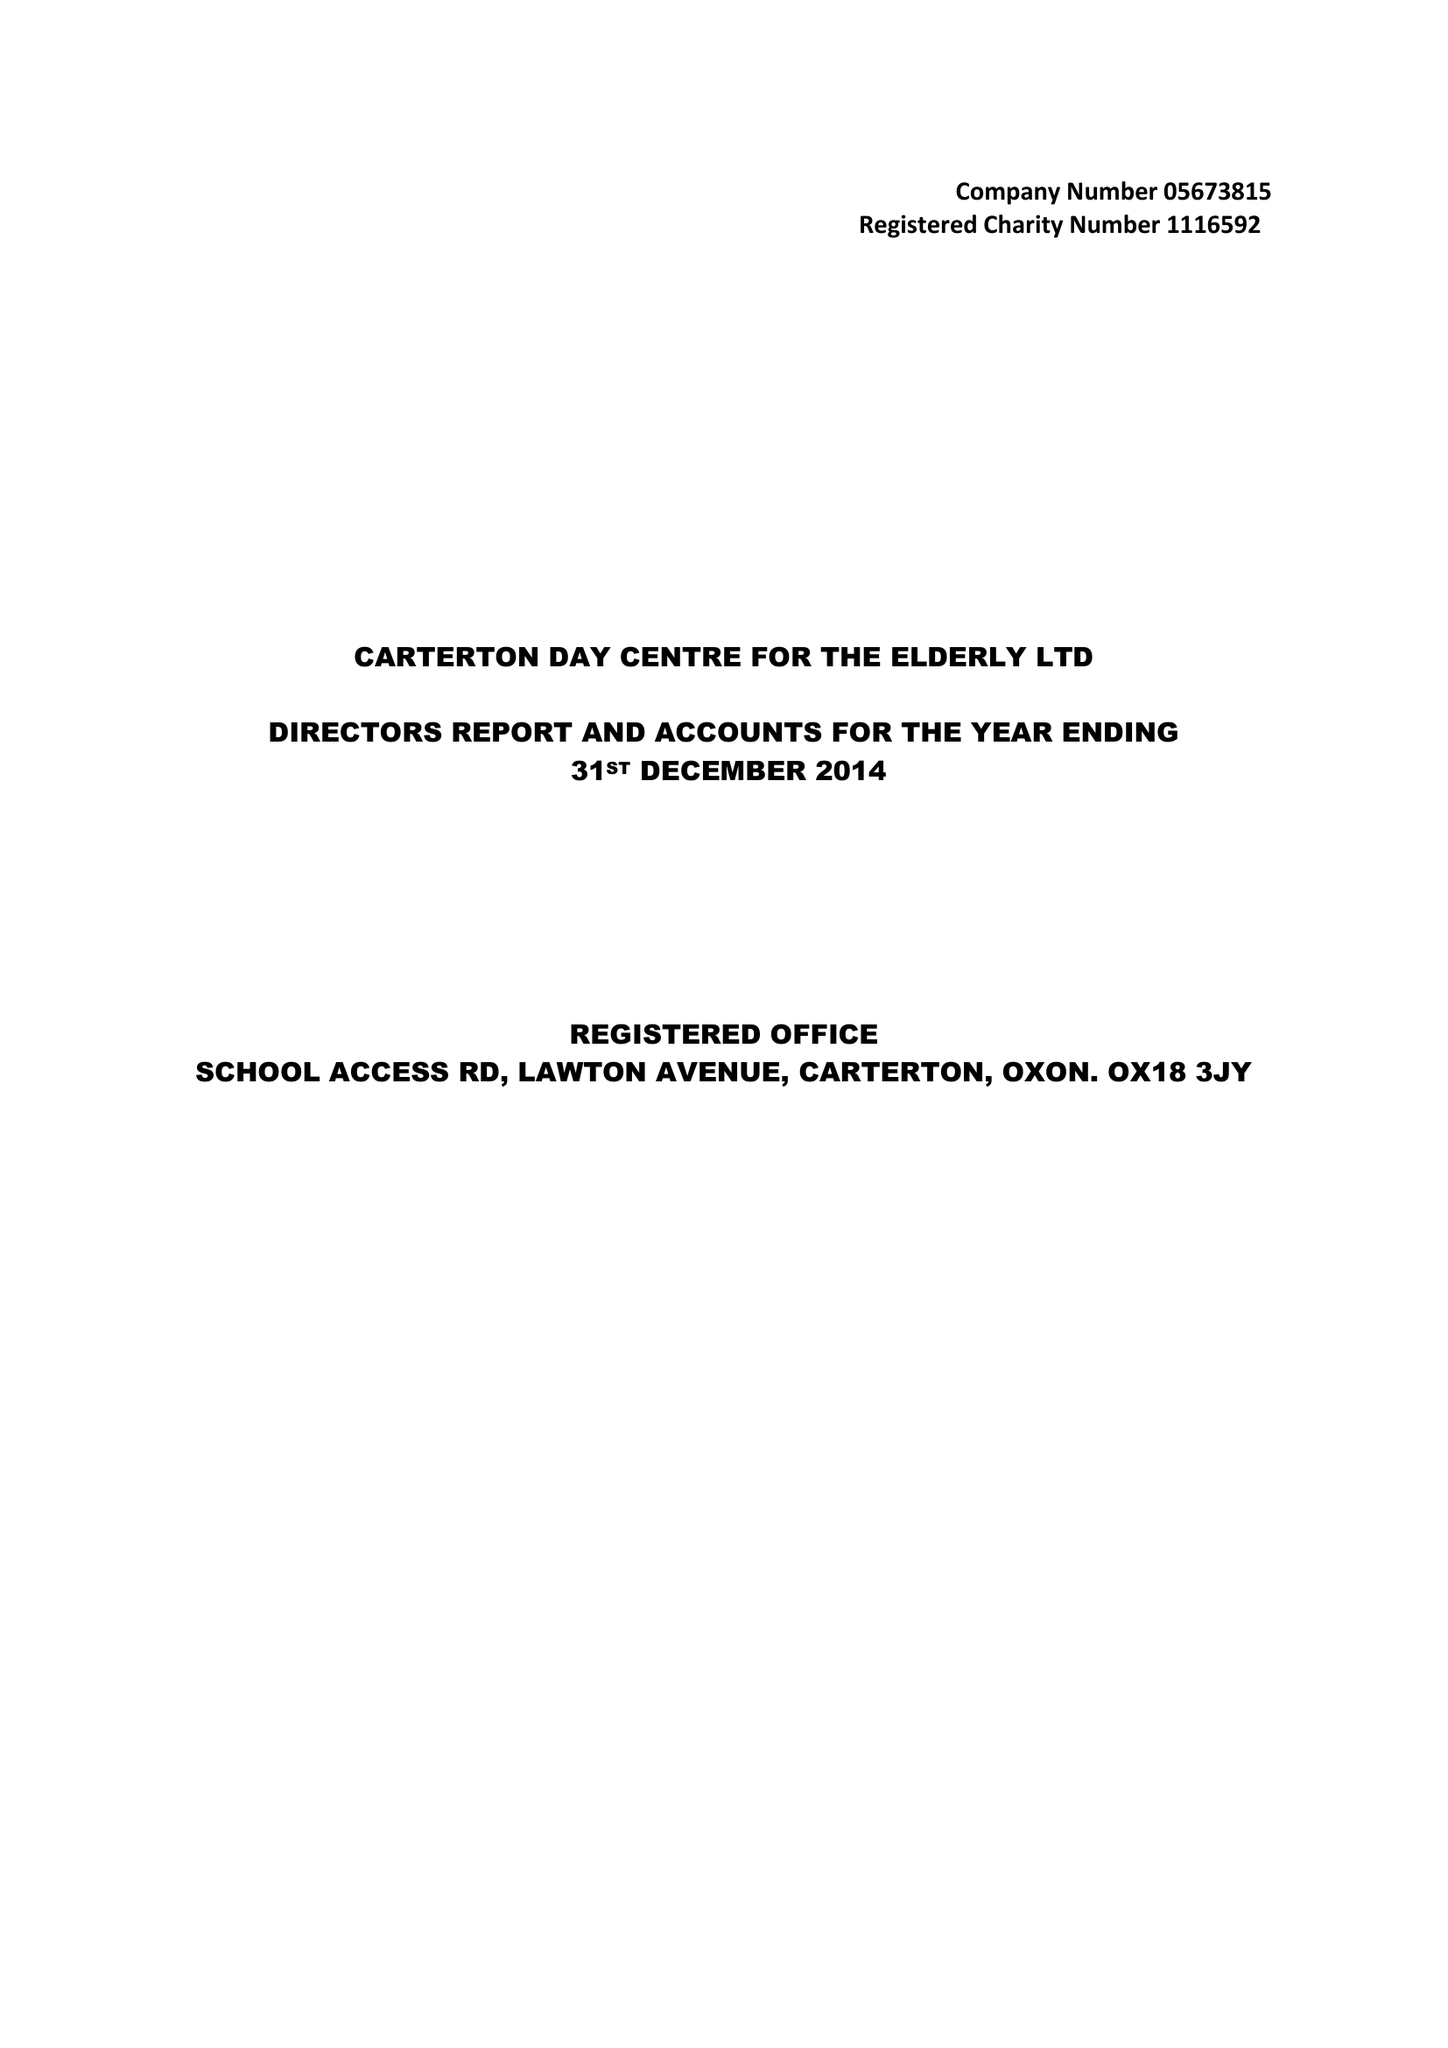What is the value for the charity_number?
Answer the question using a single word or phrase. 1116592 